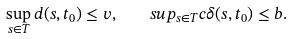Convert formula to latex. <formula><loc_0><loc_0><loc_500><loc_500>\sup _ { s \in T } d ( s , t _ { 0 } ) \leq v , \quad s u p _ { s \in T } c \delta ( s , t _ { 0 } ) \leq b .</formula> 